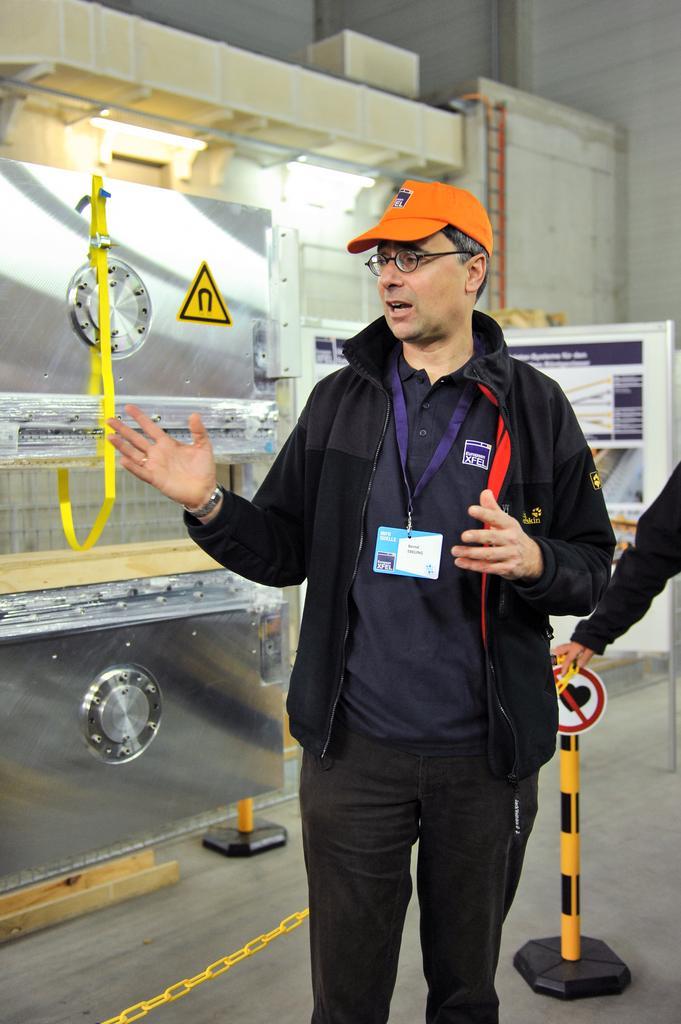Could you give a brief overview of what you see in this image? In this image, we can see a few people. We can see the ground and some metal objects. We can see the wall with some objects attached to it. We can also see a white colored object and a board with some text. We can also see a pole with a signboard and a chain. 